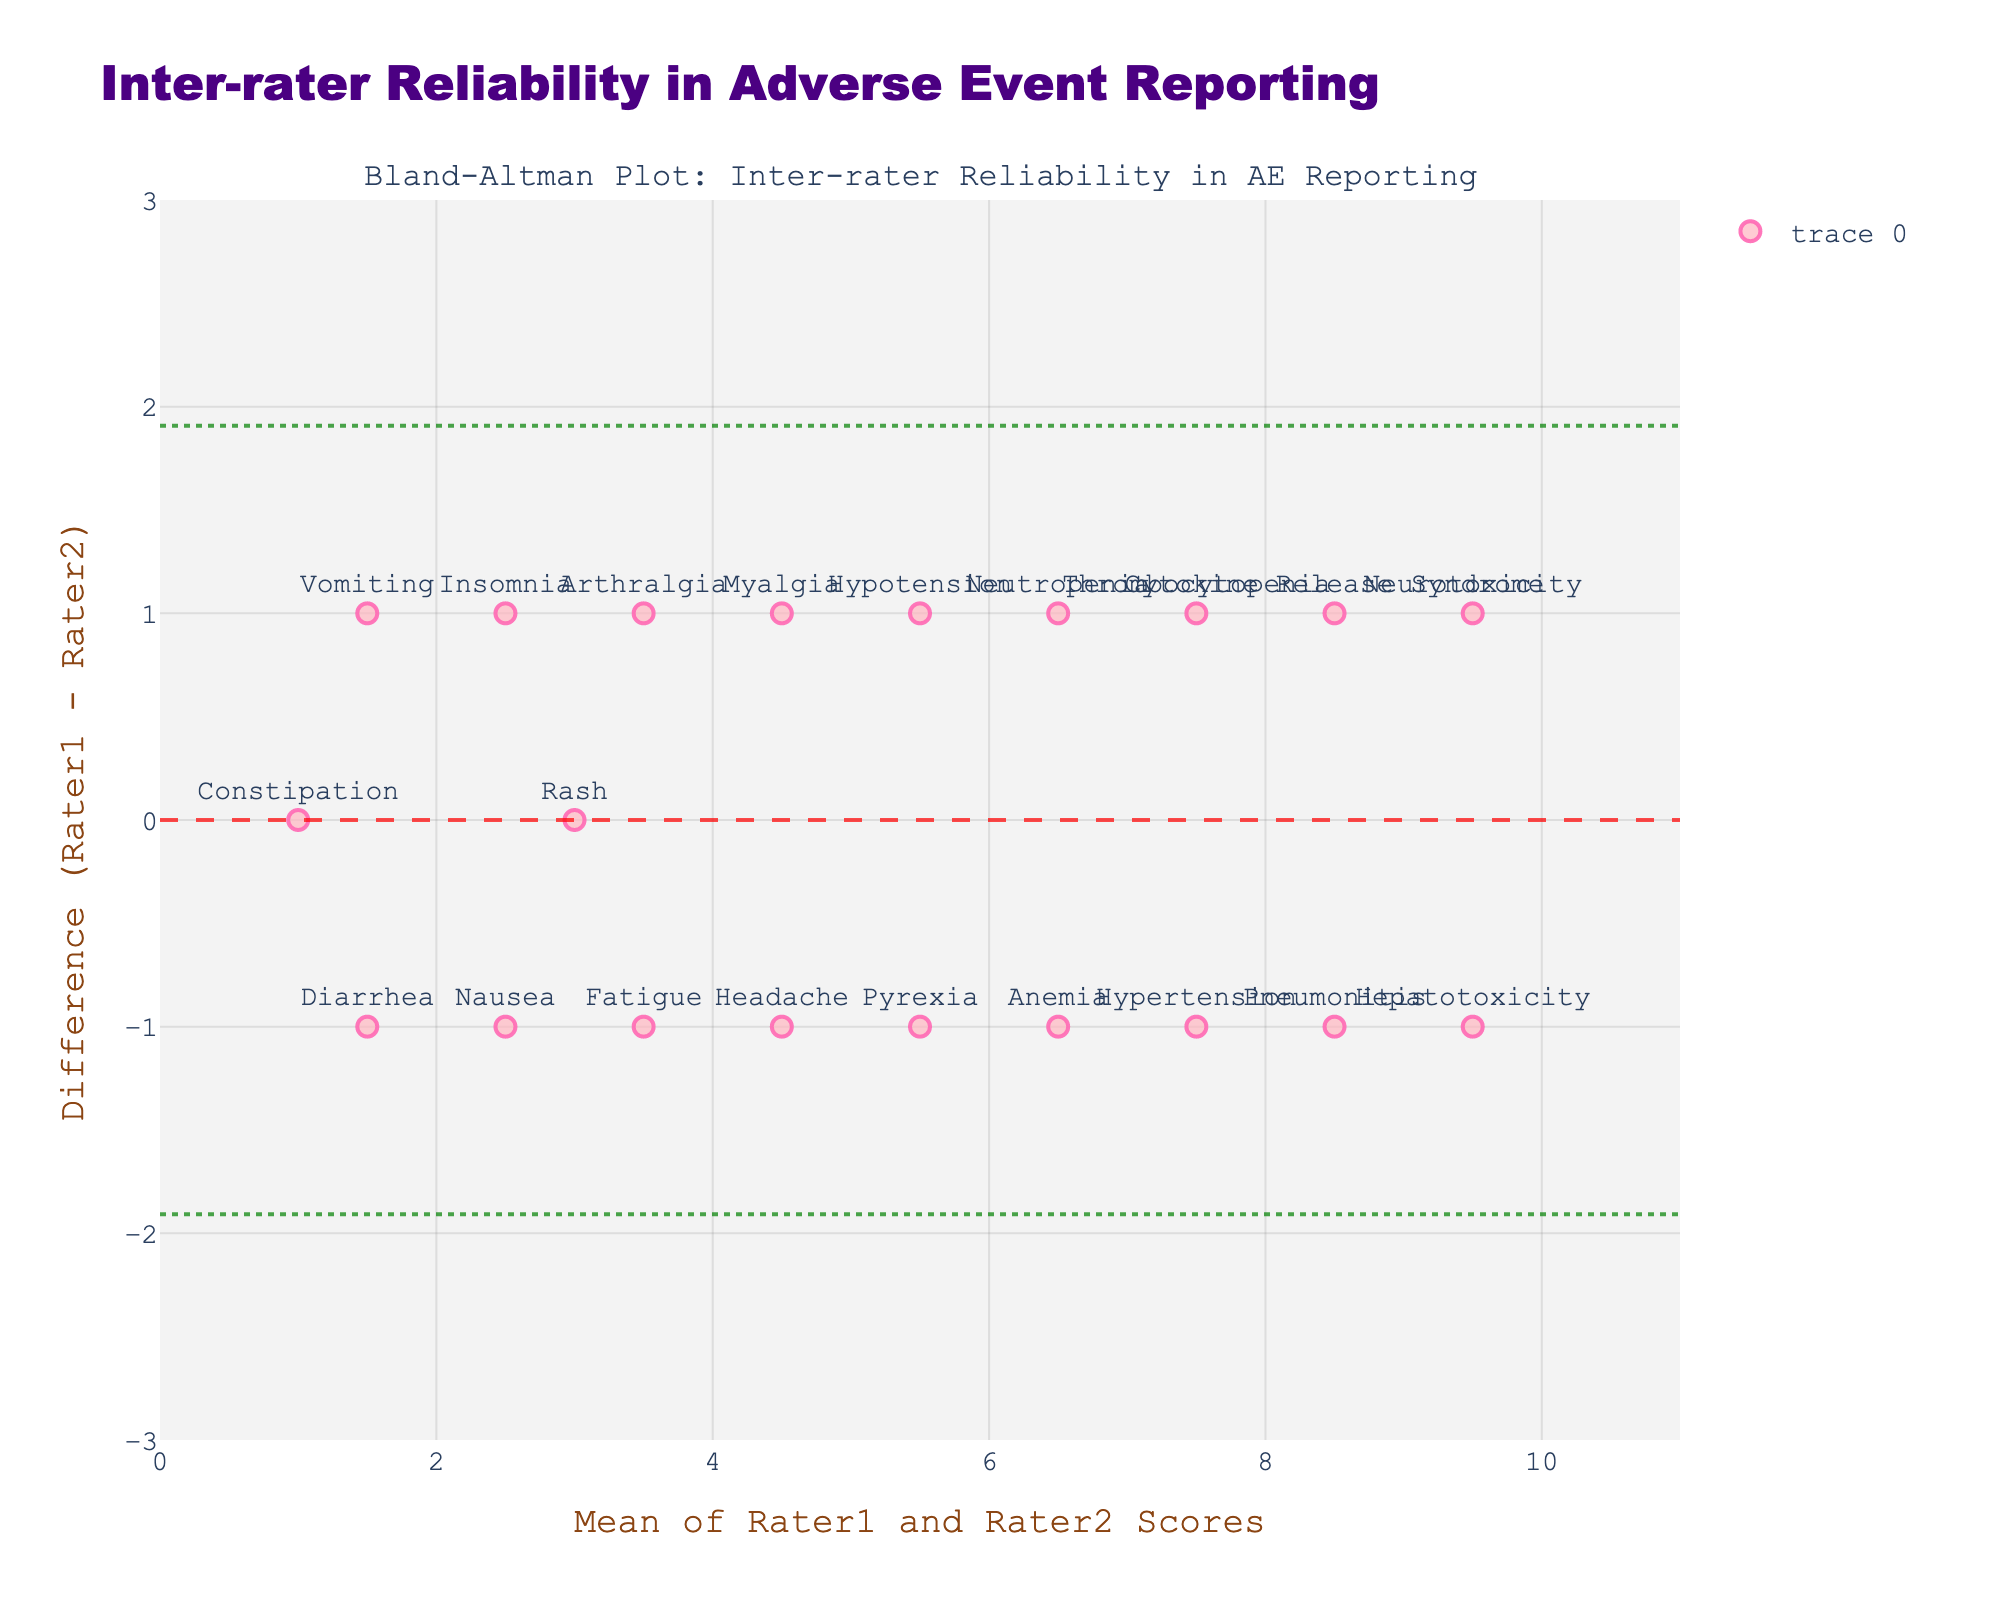What is the title of the plot? The title can be found at the top of the plot where it is typically prominently displayed.
Answer: Inter-rater Reliability in Adverse Event Reporting How many adverse event types were assessed in the plot? Each marker in the plot represents an adverse event type, and counting the markers gives the total number.
Answer: 20 What is the mean difference between the raters' scores? The mean difference is indicated by the central horizontal dashed line on the plot.
Answer: Close to 0 What kinds of adverse events have the largest discrepancy in scores between Rater 1 and Rater 2? By observing the markers that are farthest from the midline (zero difference) on the plot, we can identify the events.
Answer: Hypertension and Pneumonitis What's the most common value range in the mean scores of Rater 1 and Rater 2? The x-axis represents the mean of the scores, and the density of points in any value range indicates the frequency.
Answer: 3 to 6 Which adverse event has a mean score of approximately 10, and what is its score difference? Hovering over the marker closest to the mean score of 10 on the x-axis provides hover text with the AE type and score difference.
Answer: Neurotoxicity, -1 What are the upper and lower limits of agreement in the plot? The upper and lower horizontal dashed lines represent the limits of agreement, which are calculated as mean difference ± 1.96 standard deviations.
Answer: Upper: ~2, Lower: ~ -2 How many adverse events show a perfect agreement (no difference) between the two raters? Count the markers positioned exactly at the zero line on the y-axis.
Answer: 2 Compare the difference values for Neutropenia and Myalgia. Which one has a higher score assigned by Rater 1 compared to Rater 2? Find the markers labeled 'Neutropenia' and 'Myalgia' and compare their positions relative to the zero line on the y-axis.
Answer: Neutropenia What range of mean scores does the condition "Anemia" fall into, and what is its score difference? Locate the marker labeled 'Anemia' and use its x and y coordinates to determine the mean score and difference.
Answer: Mean: ~6.5, Difference: -1 